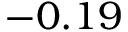Convert formula to latex. <formula><loc_0><loc_0><loc_500><loc_500>- 0 . 1 9</formula> 